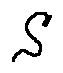Convert formula to latex. <formula><loc_0><loc_0><loc_500><loc_500>s</formula> 